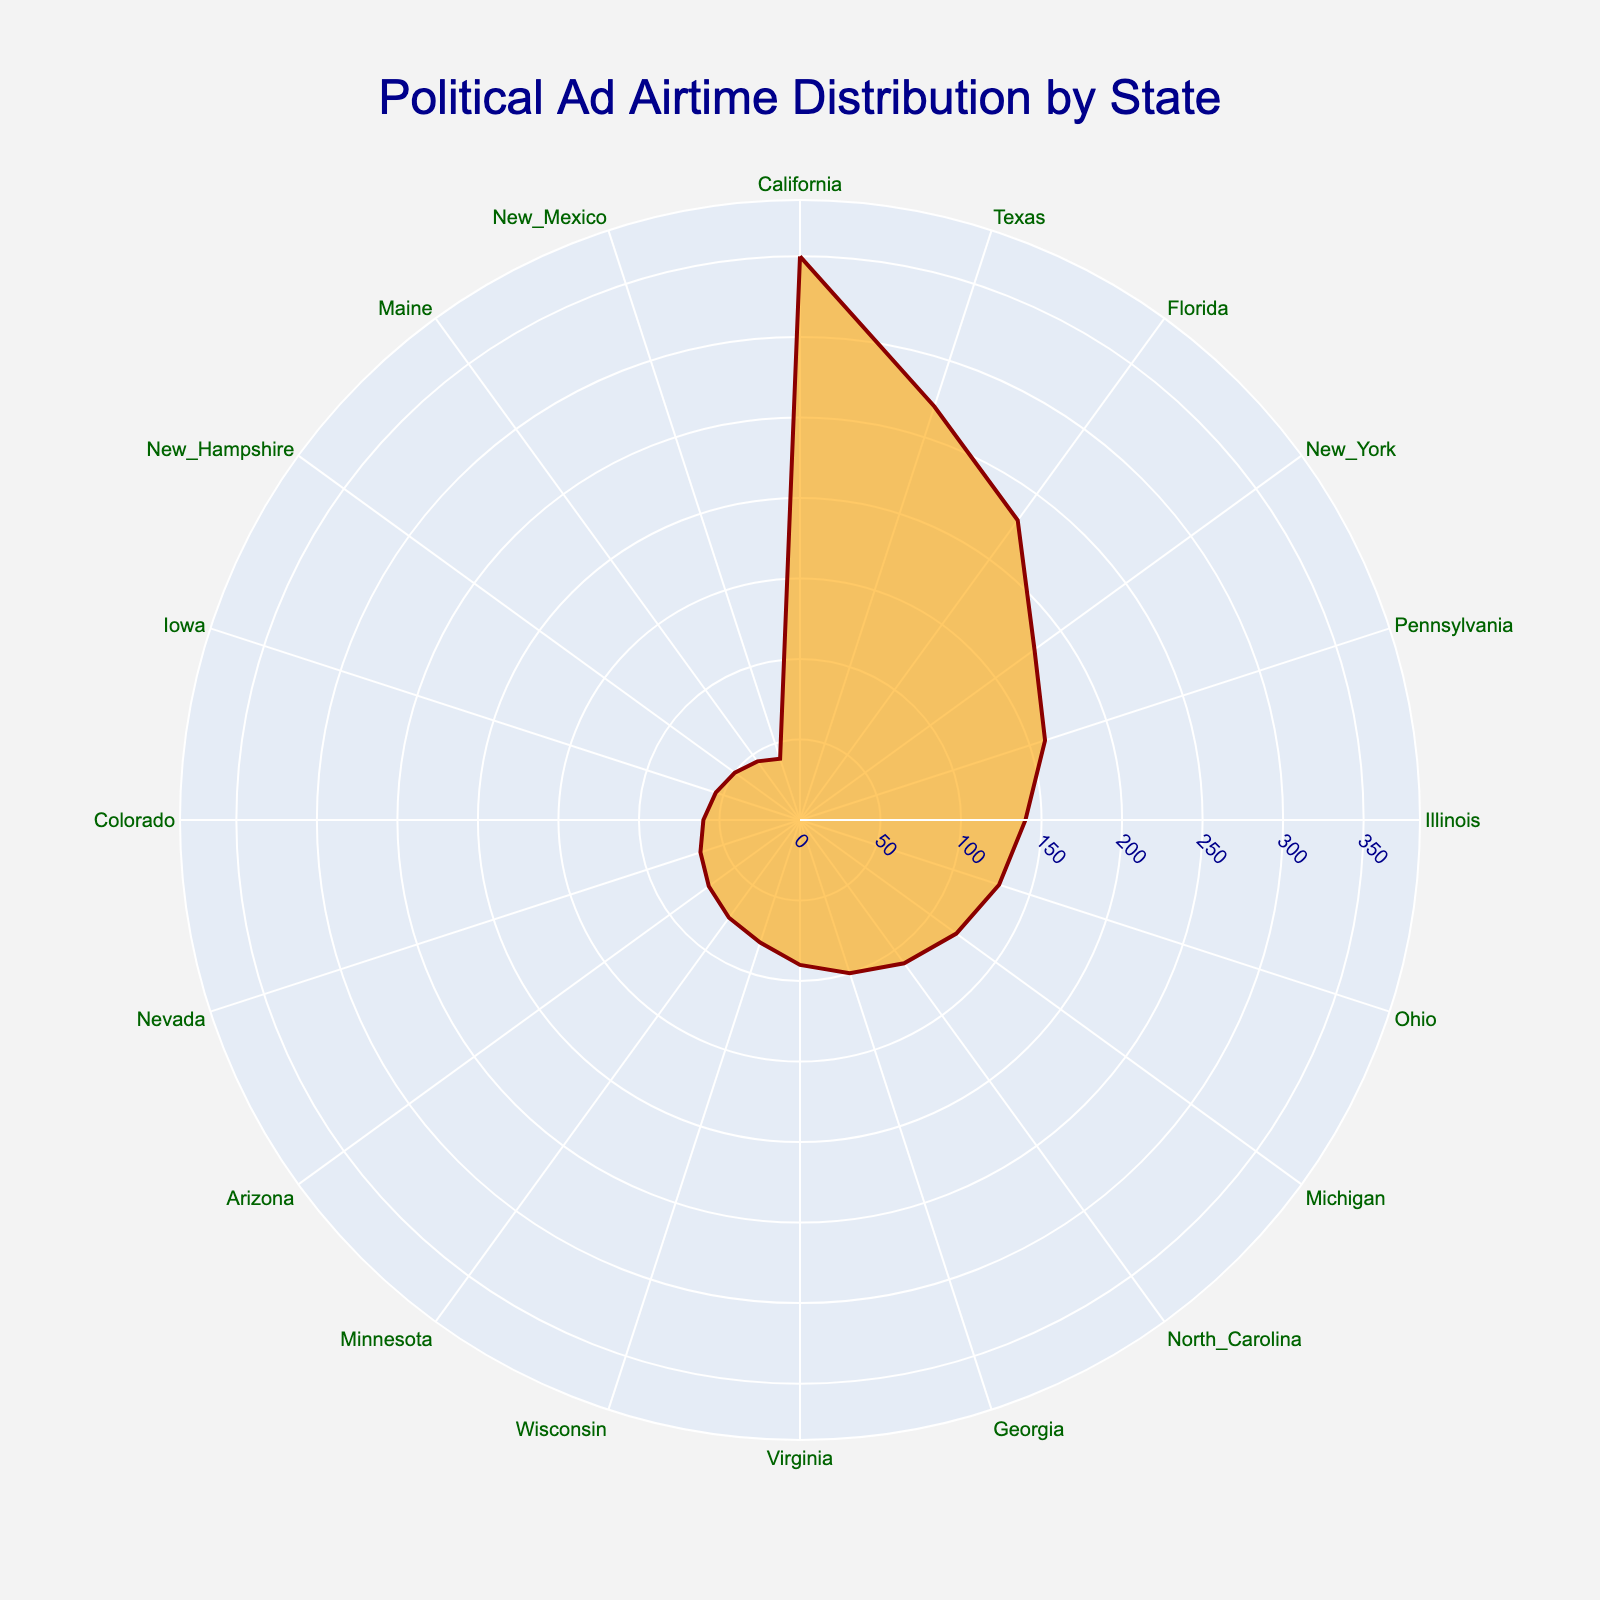What is the title of the figure? The title of the figure is displayed prominently at the top. It reads "Political Ad Airtime Distribution by State."
Answer: Political Ad Airtime Distribution by State Which state has the highest ad airtime? By observing the radial length of each segment, California has the longest segment, indicating it has the highest ad airtime.
Answer: California What is the ad airtime (in hours) for Texas? Hover over the segment corresponding to Texas, and the hover text will display "Texas: 270 hours."
Answer: 270 hours How many states have an ad airtime of 50 hours or less? By examining the radial lengths of the segments, New Hampshire, Maine, and New Mexico each have ad airtimes of 50, 45, and 40 hours respectively. Thus, there are three states.
Answer: 3 states What is the combined ad airtime for Pennsylvania and Illinois? Pennsylvania has 160 hours, and Illinois has 140 hours. Adding these together gives 160 + 140 = 300 hours.
Answer: 300 hours Which states have more airtime than Virginia but less than Ohio? Virginia has 90 hours, and Ohio has 130 hours. The states with airtime between these two values are North Carolina (110 hours), Georgia (100 hours), and Virginia.
Answer: North Carolina, Georgia What is the average ad airtime across all states shown? Sum all ad airtime hours and divide by the number of states. (350 + 270 + 230 + 180 + 160 + 140 + 130 + 120 + 110 + 100 + 90 + 80 + 75 + 70 + 65 + 60 + 55 + 50 + 45 + 40) / 20 = 160 hours.
Answer: 160 hours Identify the two states closest in ad airtime hours. By examining the radial lengths, Minnesota (75 hours) and Wisconsin (80 hours) have the closest adjoining segment lengths with a difference of 5 hours.
Answer: Minnesota and Wisconsin What percentage of the total ad airtime does California represent? Calculate the total airtime: 3500 hours. California's airtime is 350 hours. The percentage is (350/3500) * 100 = 10%.
Answer: 10% If the sector for New York were to increase by 50%, what would its new ad airtime be? New York's current airtime is 180 hours. Increasing it by 50% gives 180 + (0.5 * 180) = 180 + 90 = 270 hours.
Answer: 270 hours 